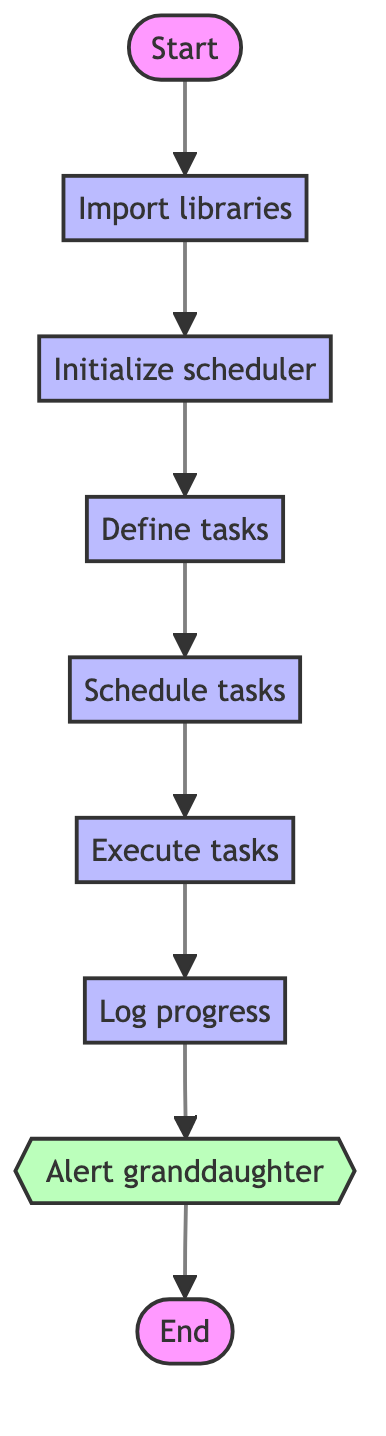What is the first step in the flowchart? The first step is labeled as "Start," indicating the beginning of the Python function.
Answer: Start How many process nodes are in the flowchart? The process nodes in the flowchart are five: "Import libraries," "Initialize scheduler," "Define tasks," "Schedule tasks," and "Execute tasks." Counting these gives five process nodes.
Answer: Five What task does the grandson perform after "Log progress"? The grandson sends a notification to move to the next task, as indicated by the subprocess node labeled "Alert granddaughter" immediately following the "Log progress" node.
Answer: Alert granddaughter Which node comes after "Schedule tasks"? The node that follows "Schedule tasks" is "Execute tasks," which illustrates the next action in the practice routine.
Answer: Execute tasks Is there an end node in the flowchart? Yes, there is an end node indicated in the flowchart, labeled "End," demonstrating the conclusion of the Python function's execution flow.
Answer: Yes What action is taken to track practice progress? The action taken to track practice progress is "Log progress," which captures the completion of each task during the practice routine.
Answer: Log progress Which node is categorized as a subprocess? The node that is categorized as a subprocess is "Alert granddaughter," demonstrating a specific action that requires notification.
Answer: Alert granddaughter How many edges connect the "Initialize scheduler" node to the next node? There is one edge connecting the "Initialize scheduler" node to the "Define tasks" node, illustrating a single pathway in the flowchart.
Answer: One What is the main function of the "Define tasks" node? The main function of the "Define tasks" node is to outline the various practice tasks, such as warm-up exercises, chord practice, and song rehearsals.
Answer: Define tasks 